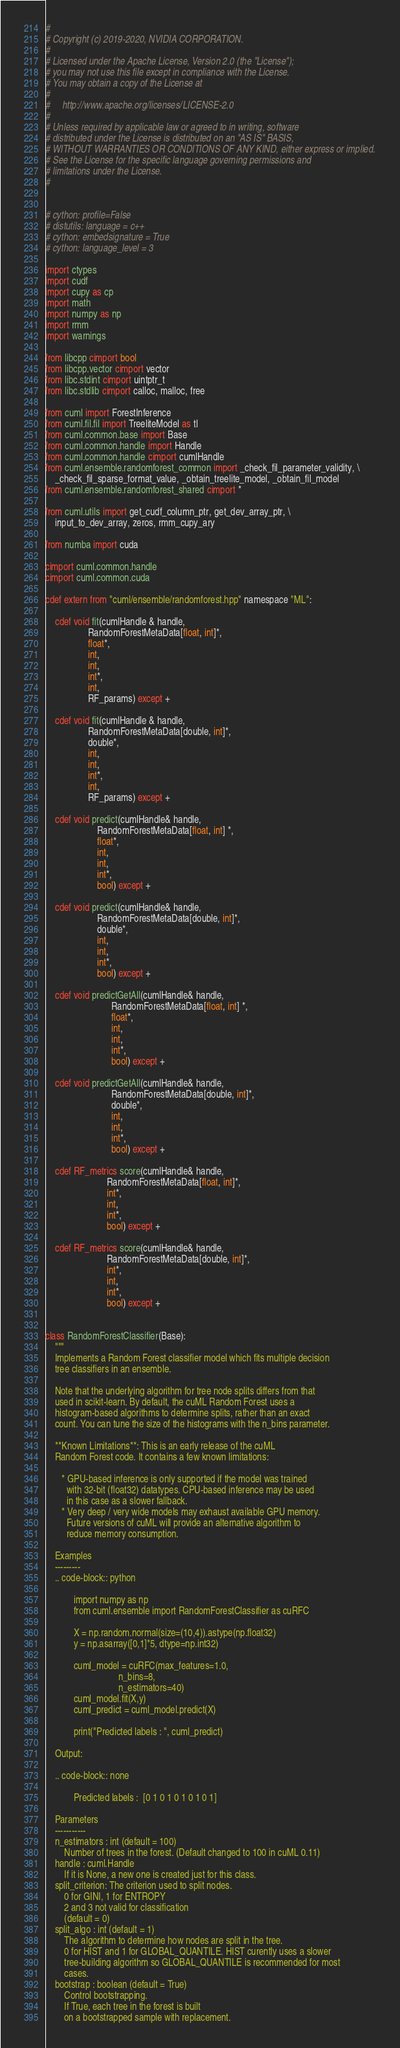Convert code to text. <code><loc_0><loc_0><loc_500><loc_500><_Cython_>#
# Copyright (c) 2019-2020, NVIDIA CORPORATION.
#
# Licensed under the Apache License, Version 2.0 (the "License");
# you may not use this file except in compliance with the License.
# You may obtain a copy of the License at
#
#     http://www.apache.org/licenses/LICENSE-2.0
#
# Unless required by applicable law or agreed to in writing, software
# distributed under the License is distributed on an "AS IS" BASIS,
# WITHOUT WARRANTIES OR CONDITIONS OF ANY KIND, either express or implied.
# See the License for the specific language governing permissions and
# limitations under the License.
#


# cython: profile=False
# distutils: language = c++
# cython: embedsignature = True
# cython: language_level = 3

import ctypes
import cudf
import cupy as cp
import math
import numpy as np
import rmm
import warnings

from libcpp cimport bool
from libcpp.vector cimport vector
from libc.stdint cimport uintptr_t
from libc.stdlib cimport calloc, malloc, free

from cuml import ForestInference
from cuml.fil.fil import TreeliteModel as tl
from cuml.common.base import Base
from cuml.common.handle import Handle
from cuml.common.handle cimport cumlHandle
from cuml.ensemble.randomforest_common import _check_fil_parameter_validity, \
    _check_fil_sparse_format_value, _obtain_treelite_model, _obtain_fil_model
from cuml.ensemble.randomforest_shared cimport *

from cuml.utils import get_cudf_column_ptr, get_dev_array_ptr, \
    input_to_dev_array, zeros, rmm_cupy_ary

from numba import cuda

cimport cuml.common.handle
cimport cuml.common.cuda

cdef extern from "cuml/ensemble/randomforest.hpp" namespace "ML":

    cdef void fit(cumlHandle & handle,
                  RandomForestMetaData[float, int]*,
                  float*,
                  int,
                  int,
                  int*,
                  int,
                  RF_params) except +

    cdef void fit(cumlHandle & handle,
                  RandomForestMetaData[double, int]*,
                  double*,
                  int,
                  int,
                  int*,
                  int,
                  RF_params) except +

    cdef void predict(cumlHandle& handle,
                      RandomForestMetaData[float, int] *,
                      float*,
                      int,
                      int,
                      int*,
                      bool) except +

    cdef void predict(cumlHandle& handle,
                      RandomForestMetaData[double, int]*,
                      double*,
                      int,
                      int,
                      int*,
                      bool) except +

    cdef void predictGetAll(cumlHandle& handle,
                            RandomForestMetaData[float, int] *,
                            float*,
                            int,
                            int,
                            int*,
                            bool) except +

    cdef void predictGetAll(cumlHandle& handle,
                            RandomForestMetaData[double, int]*,
                            double*,
                            int,
                            int,
                            int*,
                            bool) except +

    cdef RF_metrics score(cumlHandle& handle,
                          RandomForestMetaData[float, int]*,
                          int*,
                          int,
                          int*,
                          bool) except +

    cdef RF_metrics score(cumlHandle& handle,
                          RandomForestMetaData[double, int]*,
                          int*,
                          int,
                          int*,
                          bool) except +


class RandomForestClassifier(Base):
    """
    Implements a Random Forest classifier model which fits multiple decision
    tree classifiers in an ensemble.

    Note that the underlying algorithm for tree node splits differs from that
    used in scikit-learn. By default, the cuML Random Forest uses a
    histogram-based algorithms to determine splits, rather than an exact
    count. You can tune the size of the histograms with the n_bins parameter.

    **Known Limitations**: This is an early release of the cuML
    Random Forest code. It contains a few known limitations:

       * GPU-based inference is only supported if the model was trained
         with 32-bit (float32) datatypes. CPU-based inference may be used
         in this case as a slower fallback.
       * Very deep / very wide models may exhaust available GPU memory.
         Future versions of cuML will provide an alternative algorithm to
         reduce memory consumption.

    Examples
    ---------
    .. code-block:: python

            import numpy as np
            from cuml.ensemble import RandomForestClassifier as cuRFC

            X = np.random.normal(size=(10,4)).astype(np.float32)
            y = np.asarray([0,1]*5, dtype=np.int32)

            cuml_model = cuRFC(max_features=1.0,
                               n_bins=8,
                               n_estimators=40)
            cuml_model.fit(X,y)
            cuml_predict = cuml_model.predict(X)

            print("Predicted labels : ", cuml_predict)

    Output:

    .. code-block:: none

            Predicted labels :  [0 1 0 1 0 1 0 1 0 1]

    Parameters
    -----------
    n_estimators : int (default = 100)
        Number of trees in the forest. (Default changed to 100 in cuML 0.11)
    handle : cuml.Handle
        If it is None, a new one is created just for this class.
    split_criterion: The criterion used to split nodes.
        0 for GINI, 1 for ENTROPY
        2 and 3 not valid for classification
        (default = 0)
    split_algo : int (default = 1)
        The algorithm to determine how nodes are split in the tree.
        0 for HIST and 1 for GLOBAL_QUANTILE. HIST curently uses a slower
        tree-building algorithm so GLOBAL_QUANTILE is recommended for most
        cases.
    bootstrap : boolean (default = True)
        Control bootstrapping.
        If True, each tree in the forest is built
        on a bootstrapped sample with replacement.</code> 